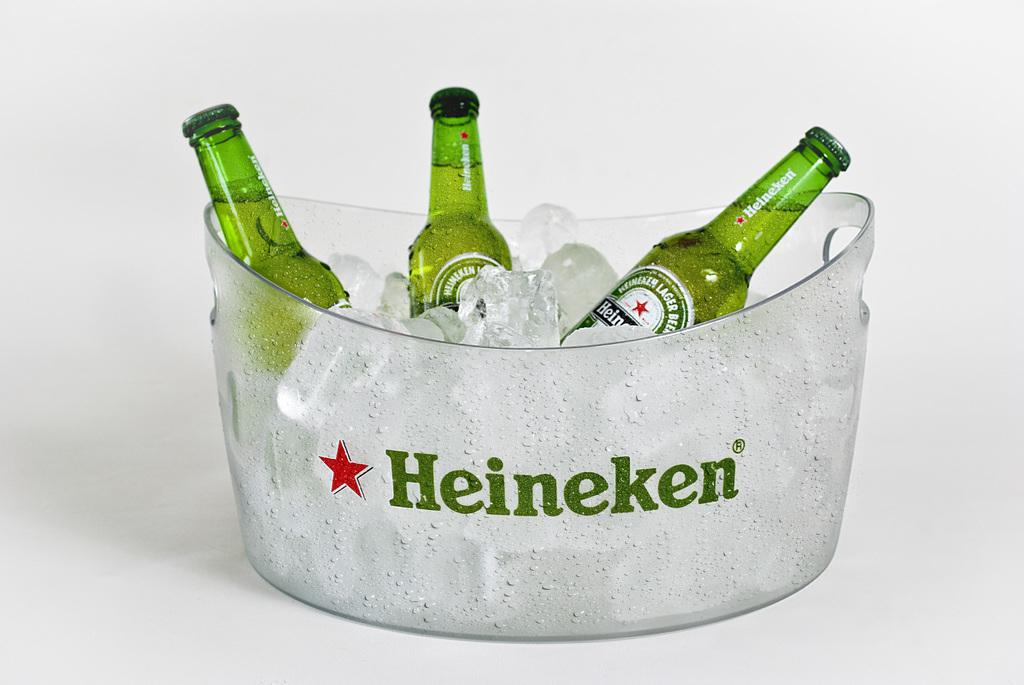How many bottles are visible in the image? There are 3 bottles in the image. What is in the bowl that is visible in the image? There is a bowl with ice in the image. What brand is associated with the bottles and the bowl? The word "Heineken" is written on one of the bottles or the bowl. What symbol is present in the image, likely associated with the Heineken branding? There is a star symbol in the image. How does the jam compare to the star symbol in the image? There is no jam present in the image, so it cannot be compared to the star symbol. 